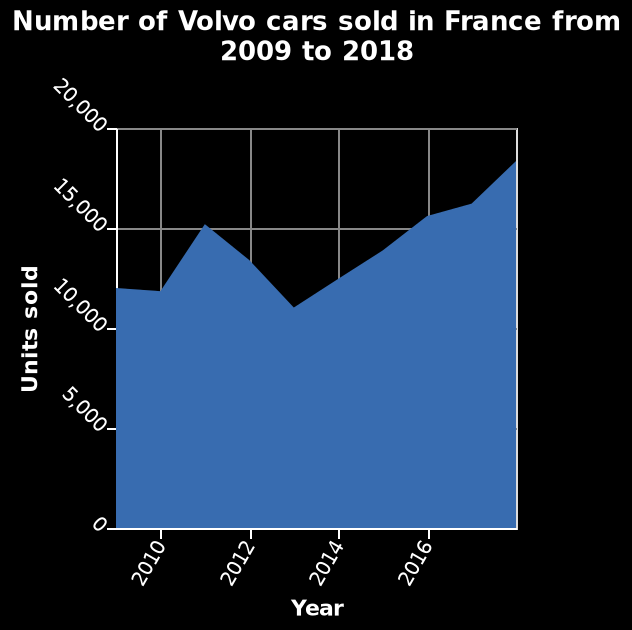<image>
Did the number of Volvo cars sold generally increase or decrease over the 9-year period? The number of Volvo cars sold generally increased over the 9-year period. 